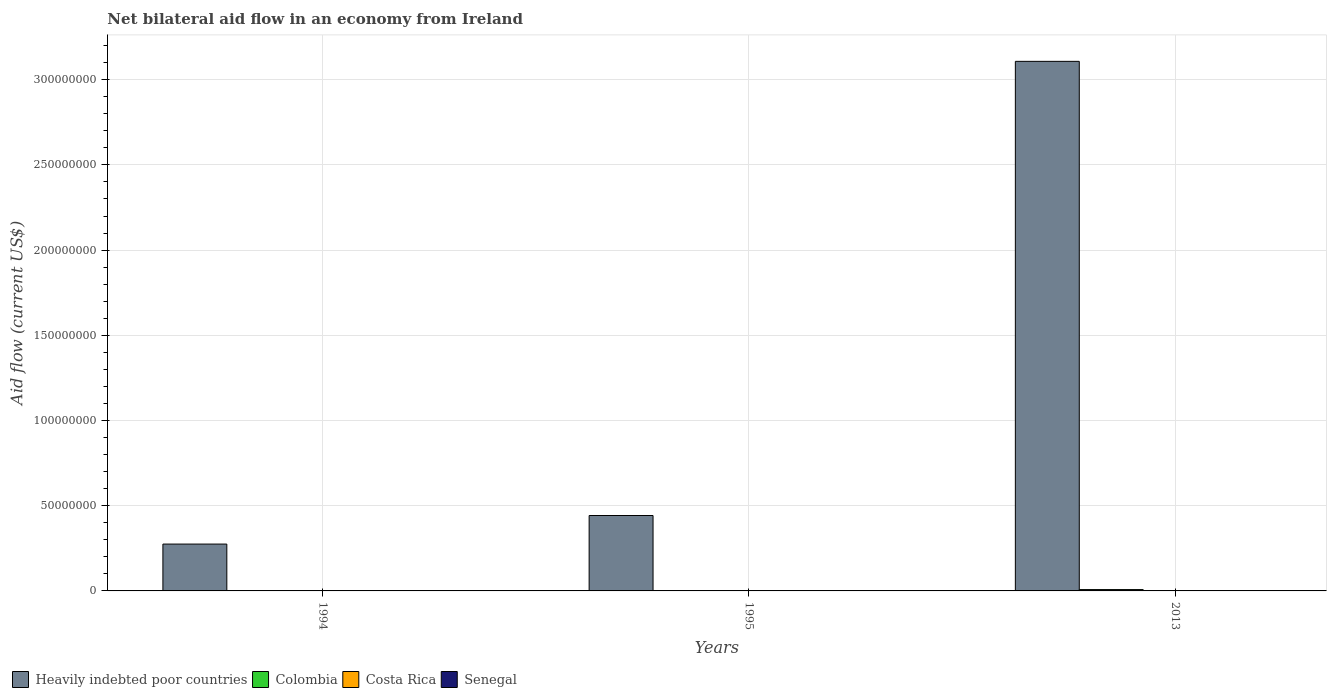How many different coloured bars are there?
Your response must be concise. 4. Are the number of bars per tick equal to the number of legend labels?
Make the answer very short. Yes. Are the number of bars on each tick of the X-axis equal?
Ensure brevity in your answer.  Yes. How many bars are there on the 2nd tick from the right?
Offer a very short reply. 4. Across all years, what is the maximum net bilateral aid flow in Costa Rica?
Give a very brief answer. 4.00e+04. Across all years, what is the minimum net bilateral aid flow in Senegal?
Ensure brevity in your answer.  2.00e+04. What is the total net bilateral aid flow in Senegal in the graph?
Your answer should be very brief. 2.20e+05. What is the difference between the net bilateral aid flow in Heavily indebted poor countries in 1994 and that in 2013?
Provide a short and direct response. -2.83e+08. What is the difference between the net bilateral aid flow in Colombia in 2013 and the net bilateral aid flow in Senegal in 1994?
Ensure brevity in your answer.  7.60e+05. What is the average net bilateral aid flow in Costa Rica per year?
Provide a succinct answer. 3.33e+04. What is the ratio of the net bilateral aid flow in Colombia in 1995 to that in 2013?
Provide a succinct answer. 0.03. Is the net bilateral aid flow in Colombia in 1995 less than that in 2013?
Your answer should be very brief. Yes. What is the difference between the highest and the second highest net bilateral aid flow in Heavily indebted poor countries?
Your answer should be compact. 2.67e+08. What is the difference between the highest and the lowest net bilateral aid flow in Colombia?
Your response must be concise. 7.60e+05. In how many years, is the net bilateral aid flow in Colombia greater than the average net bilateral aid flow in Colombia taken over all years?
Ensure brevity in your answer.  1. Is the sum of the net bilateral aid flow in Heavily indebted poor countries in 1995 and 2013 greater than the maximum net bilateral aid flow in Senegal across all years?
Offer a very short reply. Yes. What does the 1st bar from the right in 1995 represents?
Keep it short and to the point. Senegal. Is it the case that in every year, the sum of the net bilateral aid flow in Costa Rica and net bilateral aid flow in Colombia is greater than the net bilateral aid flow in Heavily indebted poor countries?
Make the answer very short. No. Are all the bars in the graph horizontal?
Provide a succinct answer. No. Are the values on the major ticks of Y-axis written in scientific E-notation?
Provide a short and direct response. No. Does the graph contain grids?
Offer a very short reply. Yes. Where does the legend appear in the graph?
Your answer should be very brief. Bottom left. How many legend labels are there?
Provide a short and direct response. 4. How are the legend labels stacked?
Your response must be concise. Horizontal. What is the title of the graph?
Give a very brief answer. Net bilateral aid flow in an economy from Ireland. Does "Antigua and Barbuda" appear as one of the legend labels in the graph?
Your answer should be compact. No. What is the Aid flow (current US$) of Heavily indebted poor countries in 1994?
Offer a terse response. 2.75e+07. What is the Aid flow (current US$) in Senegal in 1994?
Provide a succinct answer. 2.00e+04. What is the Aid flow (current US$) of Heavily indebted poor countries in 1995?
Offer a terse response. 4.42e+07. What is the Aid flow (current US$) in Colombia in 1995?
Offer a terse response. 2.00e+04. What is the Aid flow (current US$) in Costa Rica in 1995?
Offer a very short reply. 4.00e+04. What is the Aid flow (current US$) in Senegal in 1995?
Your answer should be compact. 3.00e+04. What is the Aid flow (current US$) of Heavily indebted poor countries in 2013?
Your response must be concise. 3.11e+08. What is the Aid flow (current US$) in Colombia in 2013?
Ensure brevity in your answer.  7.80e+05. What is the Aid flow (current US$) in Costa Rica in 2013?
Your answer should be compact. 3.00e+04. What is the Aid flow (current US$) of Senegal in 2013?
Offer a very short reply. 1.70e+05. Across all years, what is the maximum Aid flow (current US$) of Heavily indebted poor countries?
Ensure brevity in your answer.  3.11e+08. Across all years, what is the maximum Aid flow (current US$) of Colombia?
Keep it short and to the point. 7.80e+05. Across all years, what is the maximum Aid flow (current US$) of Costa Rica?
Make the answer very short. 4.00e+04. Across all years, what is the maximum Aid flow (current US$) in Senegal?
Your response must be concise. 1.70e+05. Across all years, what is the minimum Aid flow (current US$) of Heavily indebted poor countries?
Keep it short and to the point. 2.75e+07. What is the total Aid flow (current US$) of Heavily indebted poor countries in the graph?
Your response must be concise. 3.82e+08. What is the total Aid flow (current US$) in Colombia in the graph?
Your answer should be very brief. 8.20e+05. What is the total Aid flow (current US$) of Senegal in the graph?
Make the answer very short. 2.20e+05. What is the difference between the Aid flow (current US$) in Heavily indebted poor countries in 1994 and that in 1995?
Your response must be concise. -1.68e+07. What is the difference between the Aid flow (current US$) of Colombia in 1994 and that in 1995?
Your response must be concise. 0. What is the difference between the Aid flow (current US$) of Heavily indebted poor countries in 1994 and that in 2013?
Keep it short and to the point. -2.83e+08. What is the difference between the Aid flow (current US$) of Colombia in 1994 and that in 2013?
Your answer should be very brief. -7.60e+05. What is the difference between the Aid flow (current US$) of Heavily indebted poor countries in 1995 and that in 2013?
Ensure brevity in your answer.  -2.67e+08. What is the difference between the Aid flow (current US$) of Colombia in 1995 and that in 2013?
Your answer should be compact. -7.60e+05. What is the difference between the Aid flow (current US$) in Costa Rica in 1995 and that in 2013?
Your answer should be very brief. 10000. What is the difference between the Aid flow (current US$) of Senegal in 1995 and that in 2013?
Offer a very short reply. -1.40e+05. What is the difference between the Aid flow (current US$) of Heavily indebted poor countries in 1994 and the Aid flow (current US$) of Colombia in 1995?
Offer a very short reply. 2.75e+07. What is the difference between the Aid flow (current US$) in Heavily indebted poor countries in 1994 and the Aid flow (current US$) in Costa Rica in 1995?
Offer a very short reply. 2.74e+07. What is the difference between the Aid flow (current US$) in Heavily indebted poor countries in 1994 and the Aid flow (current US$) in Senegal in 1995?
Ensure brevity in your answer.  2.75e+07. What is the difference between the Aid flow (current US$) of Colombia in 1994 and the Aid flow (current US$) of Senegal in 1995?
Your answer should be very brief. -10000. What is the difference between the Aid flow (current US$) in Costa Rica in 1994 and the Aid flow (current US$) in Senegal in 1995?
Your answer should be compact. 0. What is the difference between the Aid flow (current US$) of Heavily indebted poor countries in 1994 and the Aid flow (current US$) of Colombia in 2013?
Your answer should be very brief. 2.67e+07. What is the difference between the Aid flow (current US$) in Heavily indebted poor countries in 1994 and the Aid flow (current US$) in Costa Rica in 2013?
Keep it short and to the point. 2.75e+07. What is the difference between the Aid flow (current US$) of Heavily indebted poor countries in 1994 and the Aid flow (current US$) of Senegal in 2013?
Provide a succinct answer. 2.73e+07. What is the difference between the Aid flow (current US$) of Colombia in 1994 and the Aid flow (current US$) of Costa Rica in 2013?
Give a very brief answer. -10000. What is the difference between the Aid flow (current US$) of Colombia in 1994 and the Aid flow (current US$) of Senegal in 2013?
Your answer should be compact. -1.50e+05. What is the difference between the Aid flow (current US$) in Heavily indebted poor countries in 1995 and the Aid flow (current US$) in Colombia in 2013?
Provide a short and direct response. 4.35e+07. What is the difference between the Aid flow (current US$) in Heavily indebted poor countries in 1995 and the Aid flow (current US$) in Costa Rica in 2013?
Your answer should be very brief. 4.42e+07. What is the difference between the Aid flow (current US$) of Heavily indebted poor countries in 1995 and the Aid flow (current US$) of Senegal in 2013?
Provide a succinct answer. 4.41e+07. What is the difference between the Aid flow (current US$) in Colombia in 1995 and the Aid flow (current US$) in Senegal in 2013?
Your answer should be very brief. -1.50e+05. What is the average Aid flow (current US$) of Heavily indebted poor countries per year?
Give a very brief answer. 1.28e+08. What is the average Aid flow (current US$) of Colombia per year?
Provide a succinct answer. 2.73e+05. What is the average Aid flow (current US$) of Costa Rica per year?
Your response must be concise. 3.33e+04. What is the average Aid flow (current US$) of Senegal per year?
Your response must be concise. 7.33e+04. In the year 1994, what is the difference between the Aid flow (current US$) in Heavily indebted poor countries and Aid flow (current US$) in Colombia?
Ensure brevity in your answer.  2.75e+07. In the year 1994, what is the difference between the Aid flow (current US$) of Heavily indebted poor countries and Aid flow (current US$) of Costa Rica?
Provide a succinct answer. 2.75e+07. In the year 1994, what is the difference between the Aid flow (current US$) of Heavily indebted poor countries and Aid flow (current US$) of Senegal?
Your answer should be compact. 2.75e+07. In the year 1994, what is the difference between the Aid flow (current US$) of Colombia and Aid flow (current US$) of Costa Rica?
Give a very brief answer. -10000. In the year 1995, what is the difference between the Aid flow (current US$) of Heavily indebted poor countries and Aid flow (current US$) of Colombia?
Offer a very short reply. 4.42e+07. In the year 1995, what is the difference between the Aid flow (current US$) of Heavily indebted poor countries and Aid flow (current US$) of Costa Rica?
Provide a short and direct response. 4.42e+07. In the year 1995, what is the difference between the Aid flow (current US$) of Heavily indebted poor countries and Aid flow (current US$) of Senegal?
Offer a very short reply. 4.42e+07. In the year 1995, what is the difference between the Aid flow (current US$) in Colombia and Aid flow (current US$) in Costa Rica?
Your answer should be compact. -2.00e+04. In the year 1995, what is the difference between the Aid flow (current US$) of Colombia and Aid flow (current US$) of Senegal?
Your answer should be compact. -10000. In the year 2013, what is the difference between the Aid flow (current US$) of Heavily indebted poor countries and Aid flow (current US$) of Colombia?
Give a very brief answer. 3.10e+08. In the year 2013, what is the difference between the Aid flow (current US$) of Heavily indebted poor countries and Aid flow (current US$) of Costa Rica?
Provide a succinct answer. 3.11e+08. In the year 2013, what is the difference between the Aid flow (current US$) in Heavily indebted poor countries and Aid flow (current US$) in Senegal?
Provide a succinct answer. 3.11e+08. In the year 2013, what is the difference between the Aid flow (current US$) of Colombia and Aid flow (current US$) of Costa Rica?
Provide a short and direct response. 7.50e+05. What is the ratio of the Aid flow (current US$) in Heavily indebted poor countries in 1994 to that in 1995?
Ensure brevity in your answer.  0.62. What is the ratio of the Aid flow (current US$) of Colombia in 1994 to that in 1995?
Keep it short and to the point. 1. What is the ratio of the Aid flow (current US$) in Senegal in 1994 to that in 1995?
Offer a terse response. 0.67. What is the ratio of the Aid flow (current US$) of Heavily indebted poor countries in 1994 to that in 2013?
Your response must be concise. 0.09. What is the ratio of the Aid flow (current US$) in Colombia in 1994 to that in 2013?
Keep it short and to the point. 0.03. What is the ratio of the Aid flow (current US$) of Costa Rica in 1994 to that in 2013?
Give a very brief answer. 1. What is the ratio of the Aid flow (current US$) in Senegal in 1994 to that in 2013?
Ensure brevity in your answer.  0.12. What is the ratio of the Aid flow (current US$) of Heavily indebted poor countries in 1995 to that in 2013?
Your answer should be compact. 0.14. What is the ratio of the Aid flow (current US$) of Colombia in 1995 to that in 2013?
Give a very brief answer. 0.03. What is the ratio of the Aid flow (current US$) in Costa Rica in 1995 to that in 2013?
Offer a very short reply. 1.33. What is the ratio of the Aid flow (current US$) of Senegal in 1995 to that in 2013?
Ensure brevity in your answer.  0.18. What is the difference between the highest and the second highest Aid flow (current US$) in Heavily indebted poor countries?
Keep it short and to the point. 2.67e+08. What is the difference between the highest and the second highest Aid flow (current US$) in Colombia?
Make the answer very short. 7.60e+05. What is the difference between the highest and the lowest Aid flow (current US$) of Heavily indebted poor countries?
Keep it short and to the point. 2.83e+08. What is the difference between the highest and the lowest Aid flow (current US$) of Colombia?
Offer a very short reply. 7.60e+05. What is the difference between the highest and the lowest Aid flow (current US$) in Costa Rica?
Ensure brevity in your answer.  10000. 